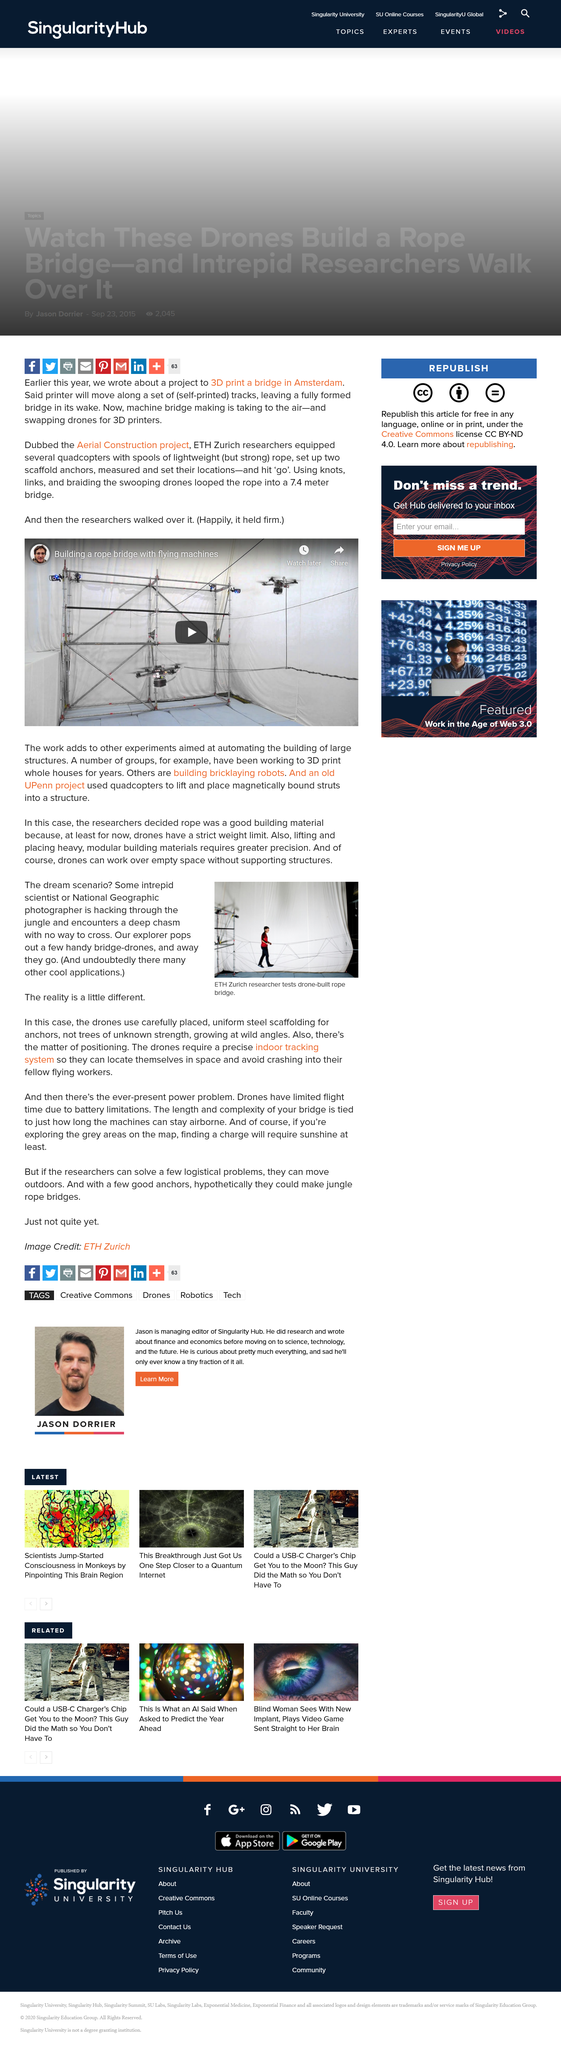List a handful of essential elements in this visual. The researchers determined that the rope was an effective building material in this instance. The project to 3D print a bridge in Amsterdam is called the Aerial Construction Project. The drones, which can operate effectively in the absence of supporting structures over vast distances, are a testament to the remarkable advancements in technology that have made such feats possible. ETH Zurich researcher successfully tested a drone-built rope bridge, demonstrating the potential for this innovative technology in the field of civil engineering. The bridge held firm when the engineers walked on it, as evidenced by the fact that it did not collapse. 